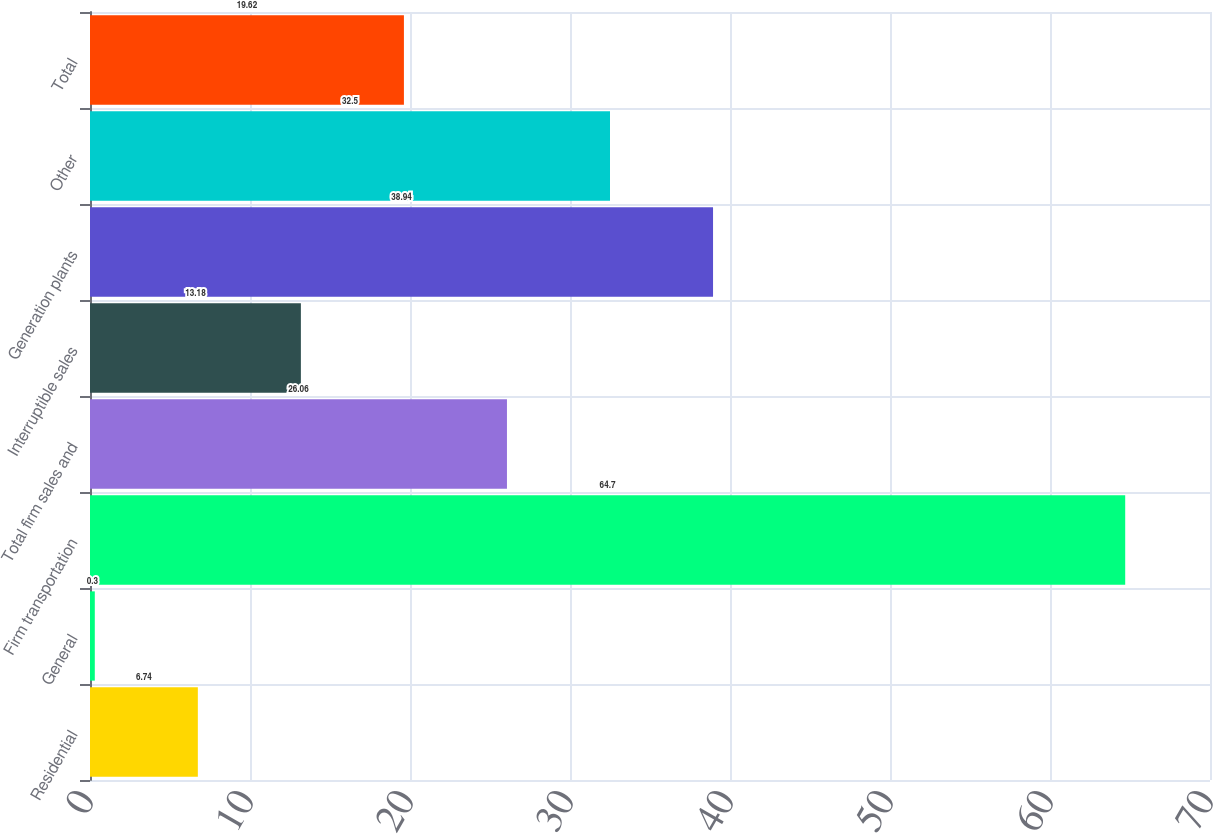<chart> <loc_0><loc_0><loc_500><loc_500><bar_chart><fcel>Residential<fcel>General<fcel>Firm transportation<fcel>Total firm sales and<fcel>Interruptible sales<fcel>Generation plants<fcel>Other<fcel>Total<nl><fcel>6.74<fcel>0.3<fcel>64.7<fcel>26.06<fcel>13.18<fcel>38.94<fcel>32.5<fcel>19.62<nl></chart> 